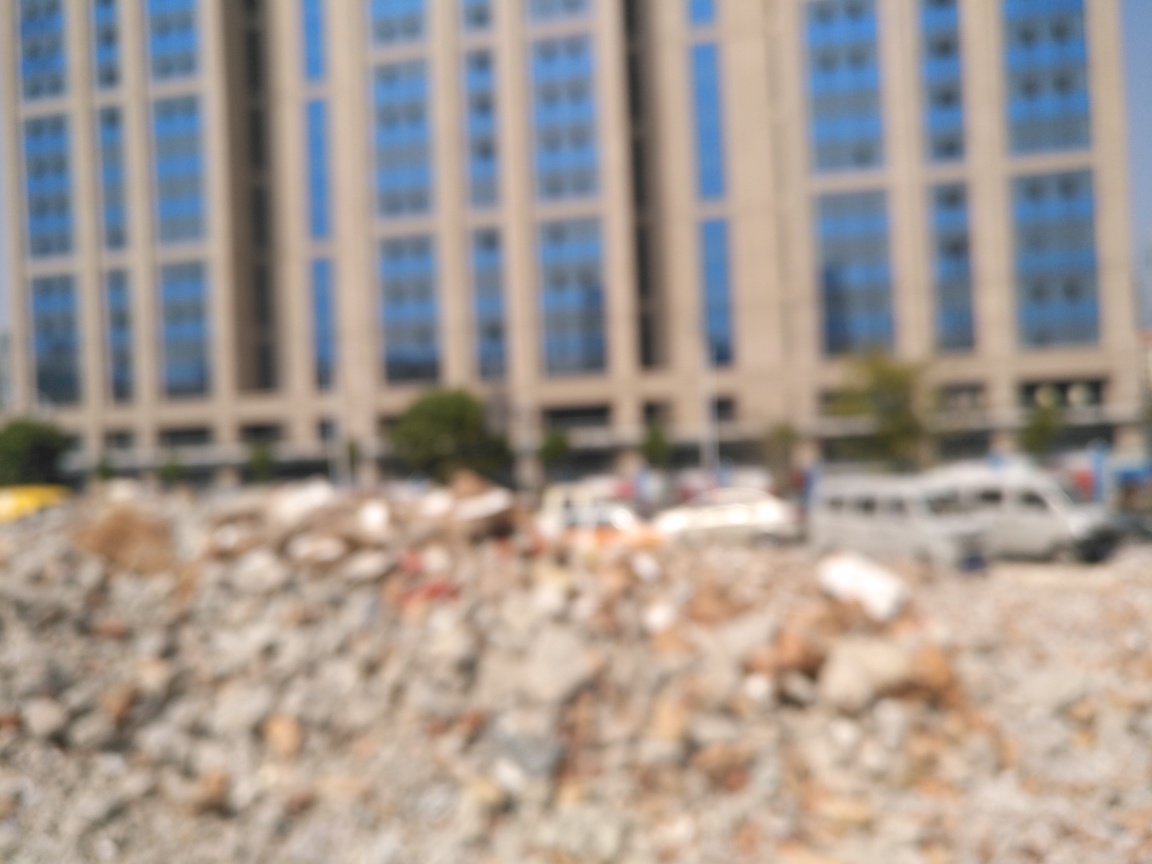What emotions or themes might this image evoke based on its composition and content? The combination of a blurred urban setting and what might be a demolished area could evoke feelings of uncertainty, transition, or chaos. It might indicate themes of urban change, the impermanence of structures, or the progress of construction and development. 